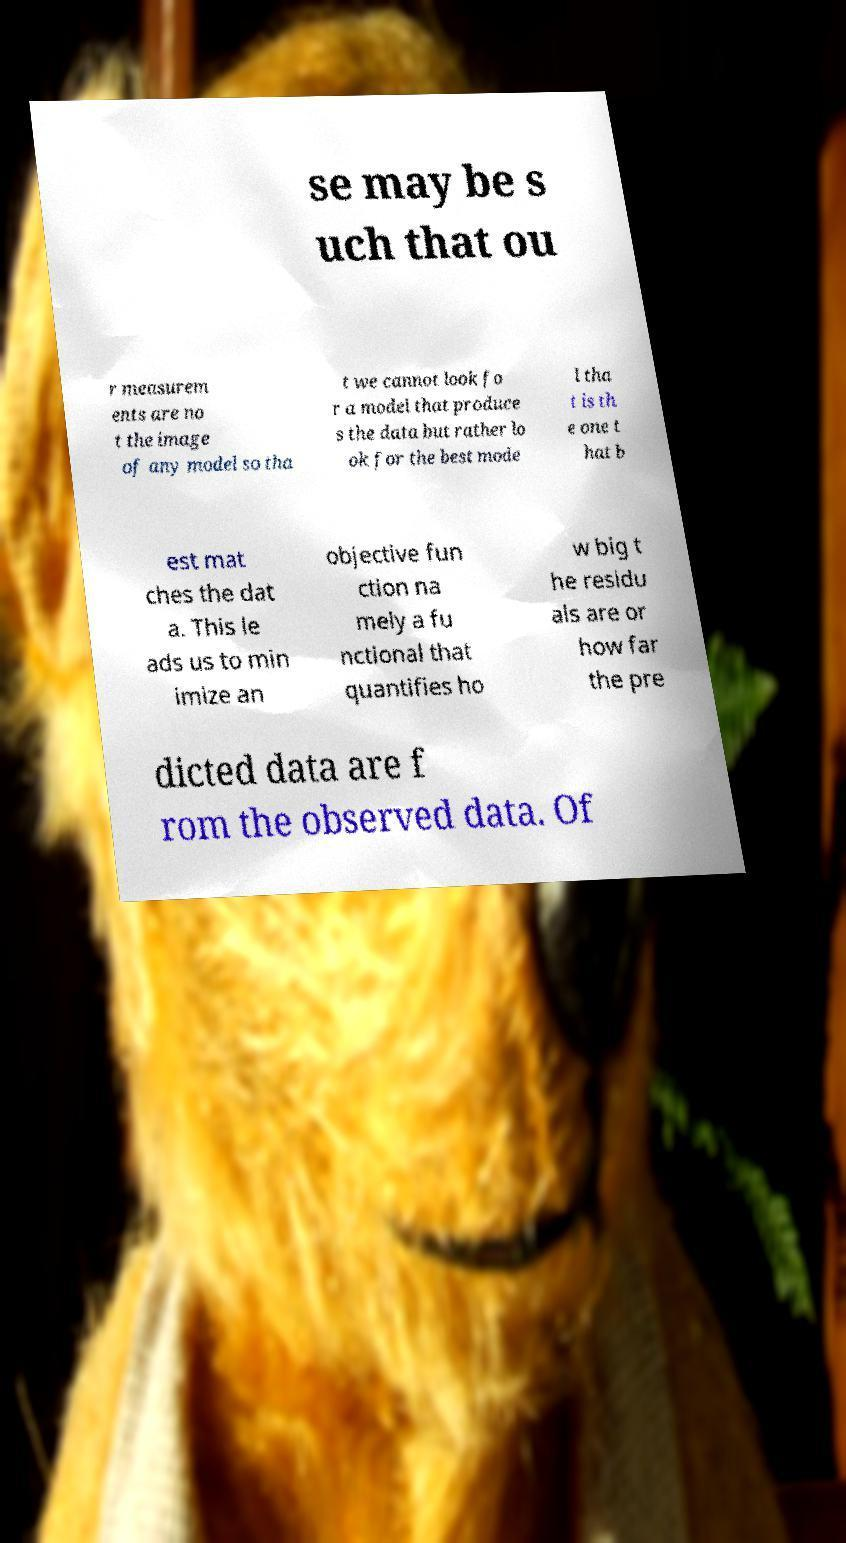Could you assist in decoding the text presented in this image and type it out clearly? se may be s uch that ou r measurem ents are no t the image of any model so tha t we cannot look fo r a model that produce s the data but rather lo ok for the best mode l tha t is th e one t hat b est mat ches the dat a. This le ads us to min imize an objective fun ction na mely a fu nctional that quantifies ho w big t he residu als are or how far the pre dicted data are f rom the observed data. Of 